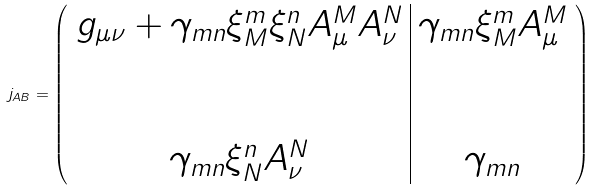<formula> <loc_0><loc_0><loc_500><loc_500>j _ { A B } = \left ( \begin{array} { c | c } g _ { \mu \nu } + \gamma _ { m n } \xi ^ { m } _ { M } \xi ^ { n } _ { N } A ^ { M } _ { \mu } A ^ { N } _ { \nu } & \gamma _ { m n } \xi ^ { m } _ { M } A ^ { M } _ { \mu } \\ \\ \\ \gamma _ { m n } \xi ^ { n } _ { N } A ^ { N } _ { \nu } & \gamma _ { m n } \end{array} \right )</formula> 